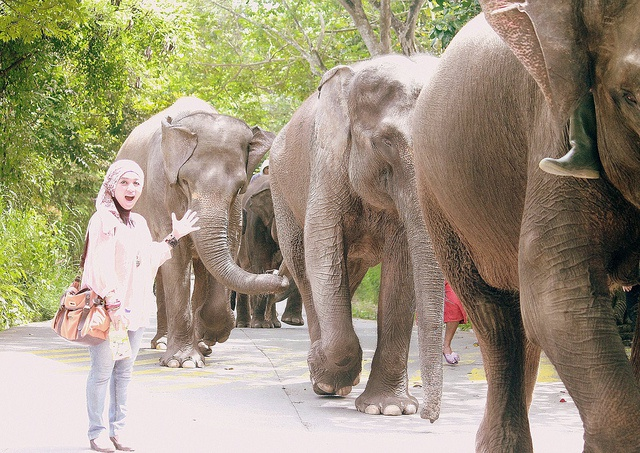Describe the objects in this image and their specific colors. I can see elephant in khaki, gray, and black tones, elephant in khaki, darkgray, gray, and lightgray tones, elephant in khaki, darkgray, gray, and lightgray tones, people in khaki, lightgray, darkgray, and lightpink tones, and elephant in khaki, gray, black, and darkgray tones in this image. 